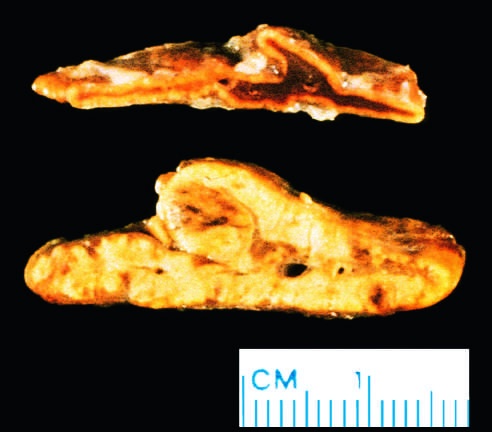what is contrasted with a normal adrenal gland?
Answer the question using a single word or phrase. Diffuse hyperplasia of the adrenal gland 